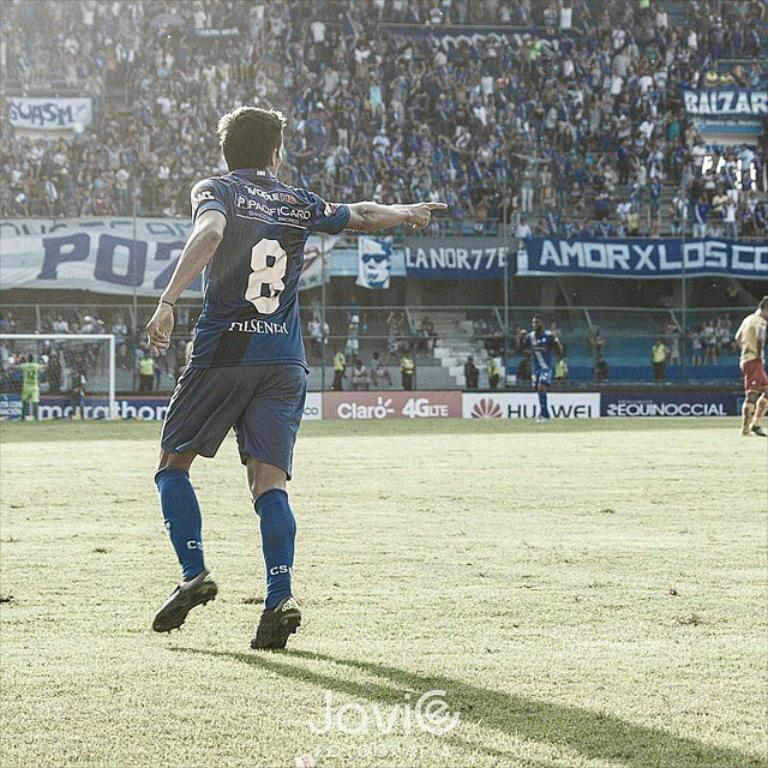What number is on the jersey?
Provide a succinct answer. 8. 